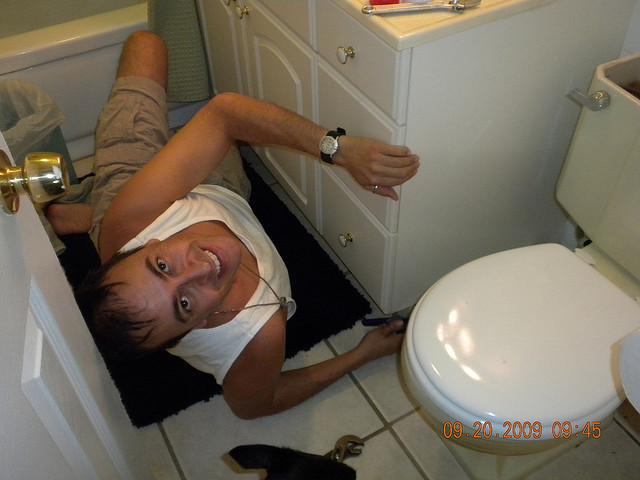What kind of shirt is the man wearing?
Concise answer only. Tank top. What date was this photo taken?
Answer briefly. 09/20/2009. Is the man fixing the toilet?
Quick response, please. Yes. 